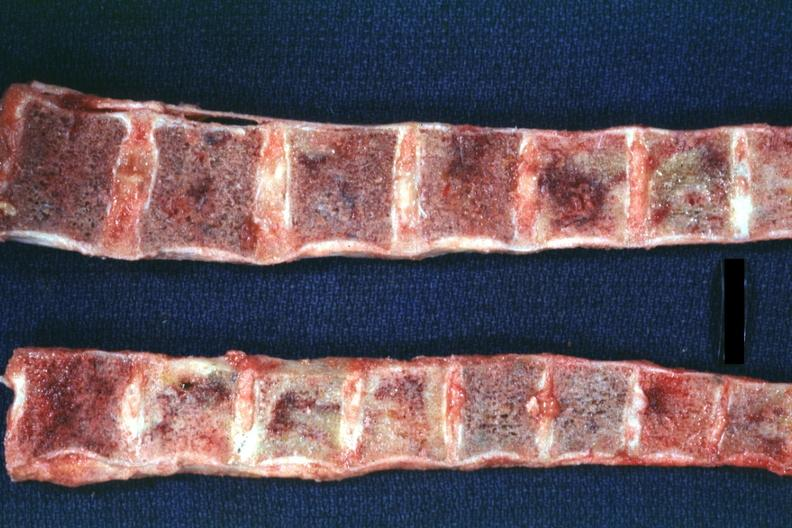s joints present?
Answer the question using a single word or phrase. Yes 